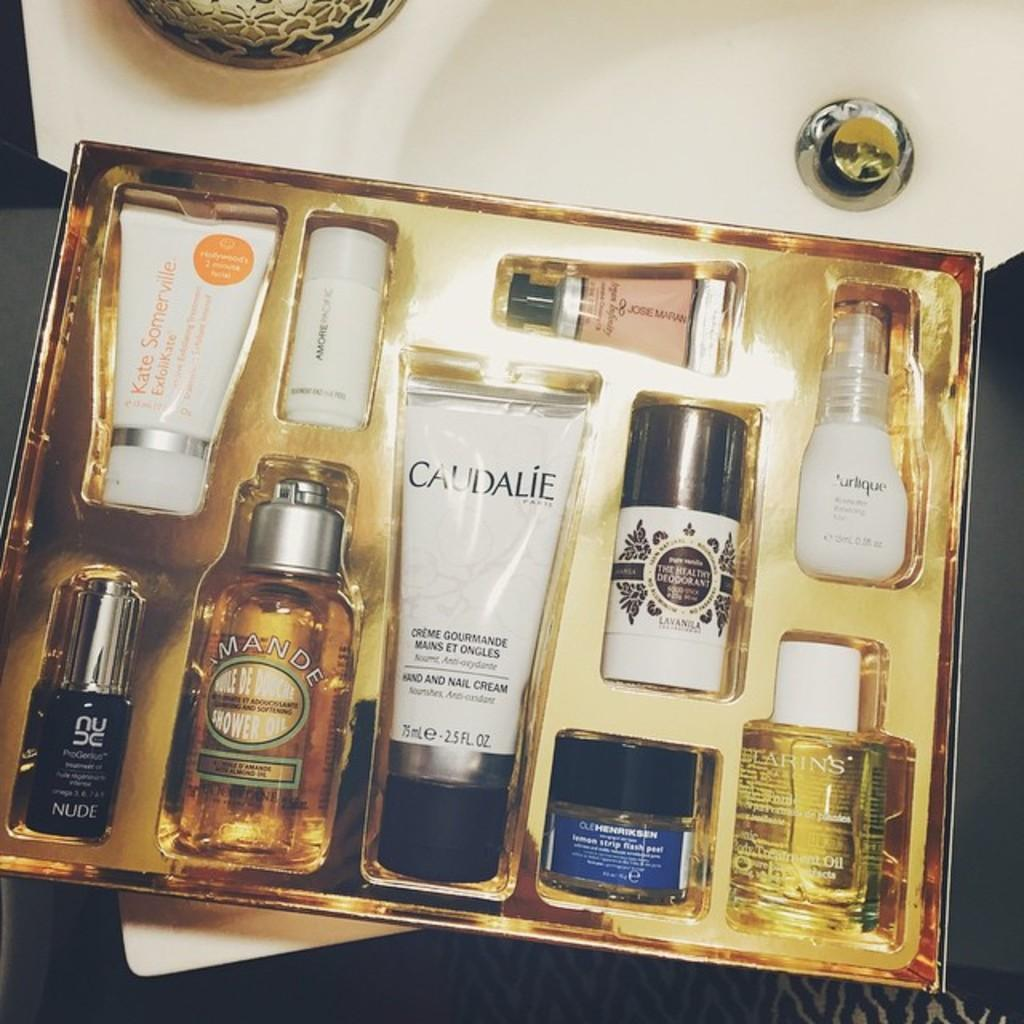<image>
Describe the image concisely. A gift set of toiletry products from Caudale brand. 